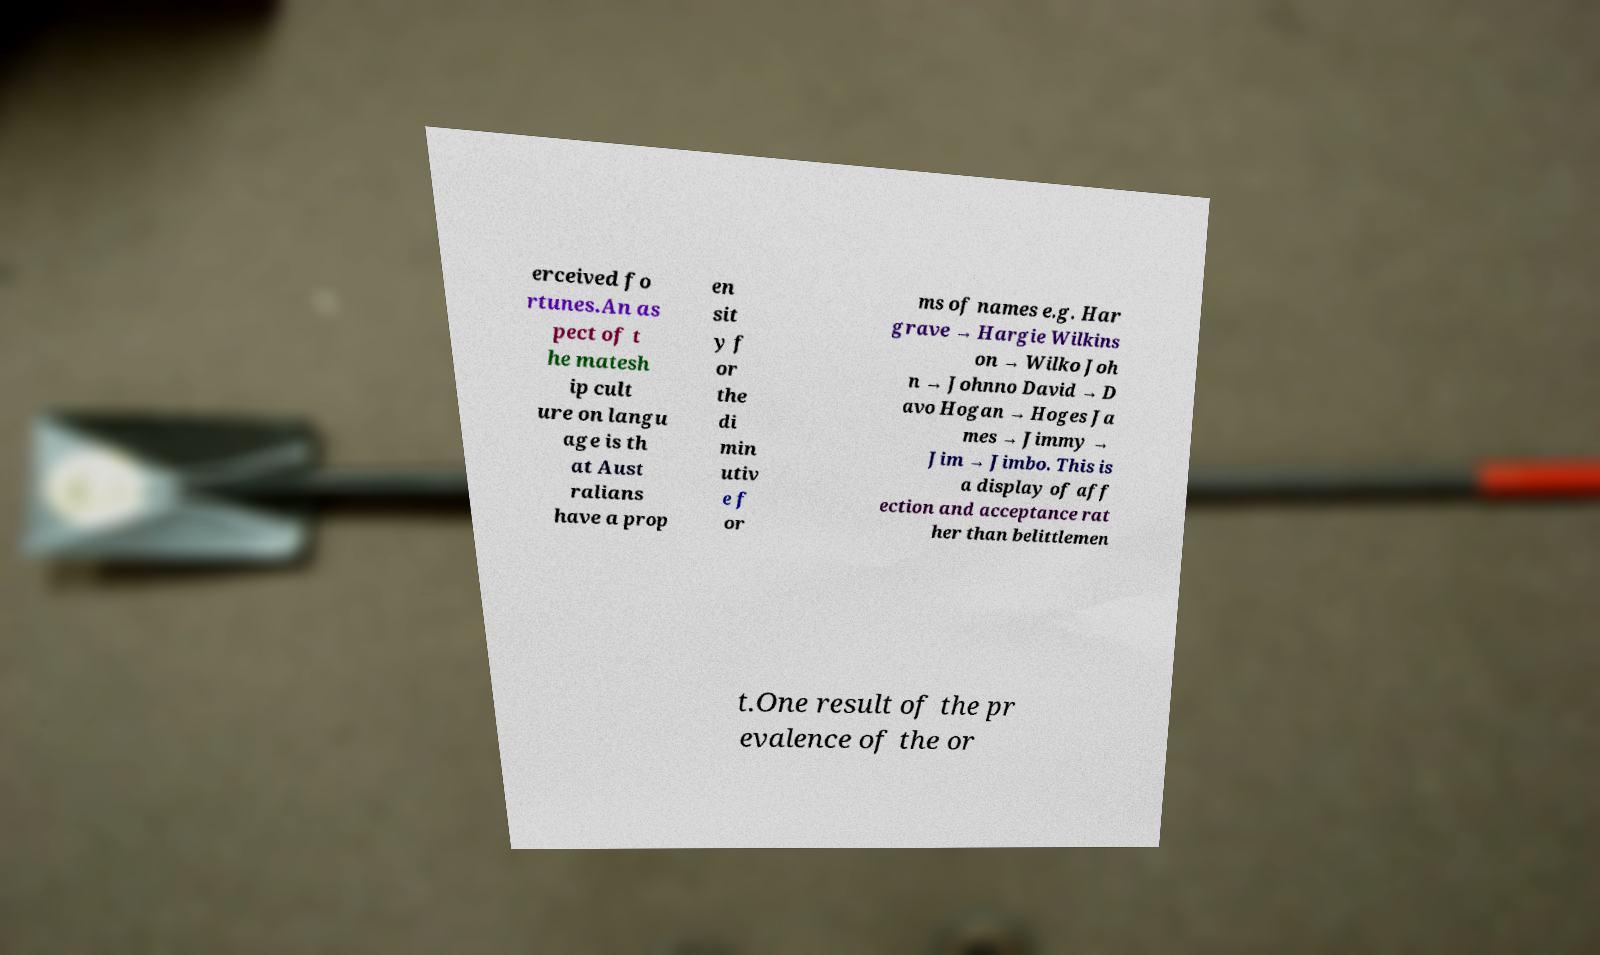Please identify and transcribe the text found in this image. erceived fo rtunes.An as pect of t he matesh ip cult ure on langu age is th at Aust ralians have a prop en sit y f or the di min utiv e f or ms of names e.g. Har grave → Hargie Wilkins on → Wilko Joh n → Johnno David → D avo Hogan → Hoges Ja mes → Jimmy → Jim → Jimbo. This is a display of aff ection and acceptance rat her than belittlemen t.One result of the pr evalence of the or 